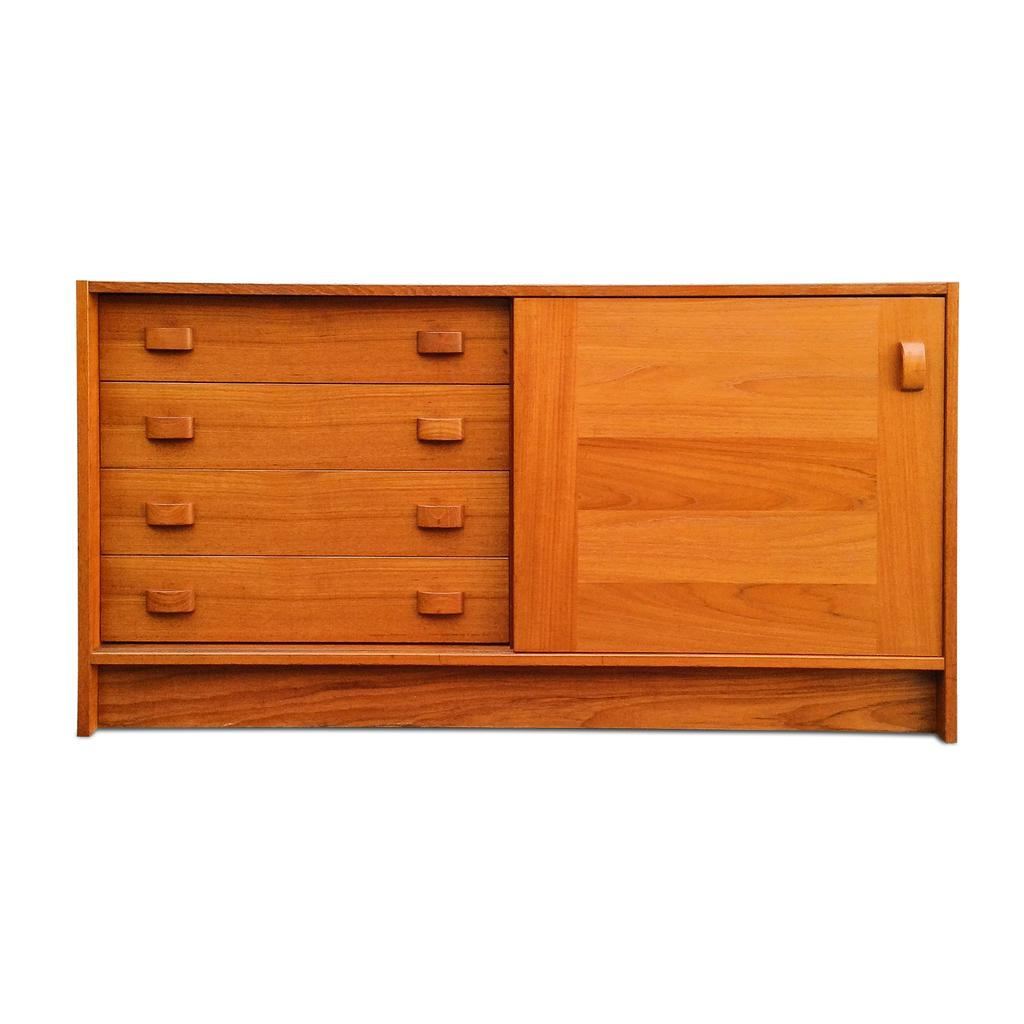What type of furniture is present in the image? There is a cupboard in the image. What can be seen at the top of the image? There is brightness visible at the top of the image. How many rods are hanging from the cupboard in the image? There are no rods hanging from the cupboard in the image. What type of pig can be seen in the image? There is no pig present in the image. 